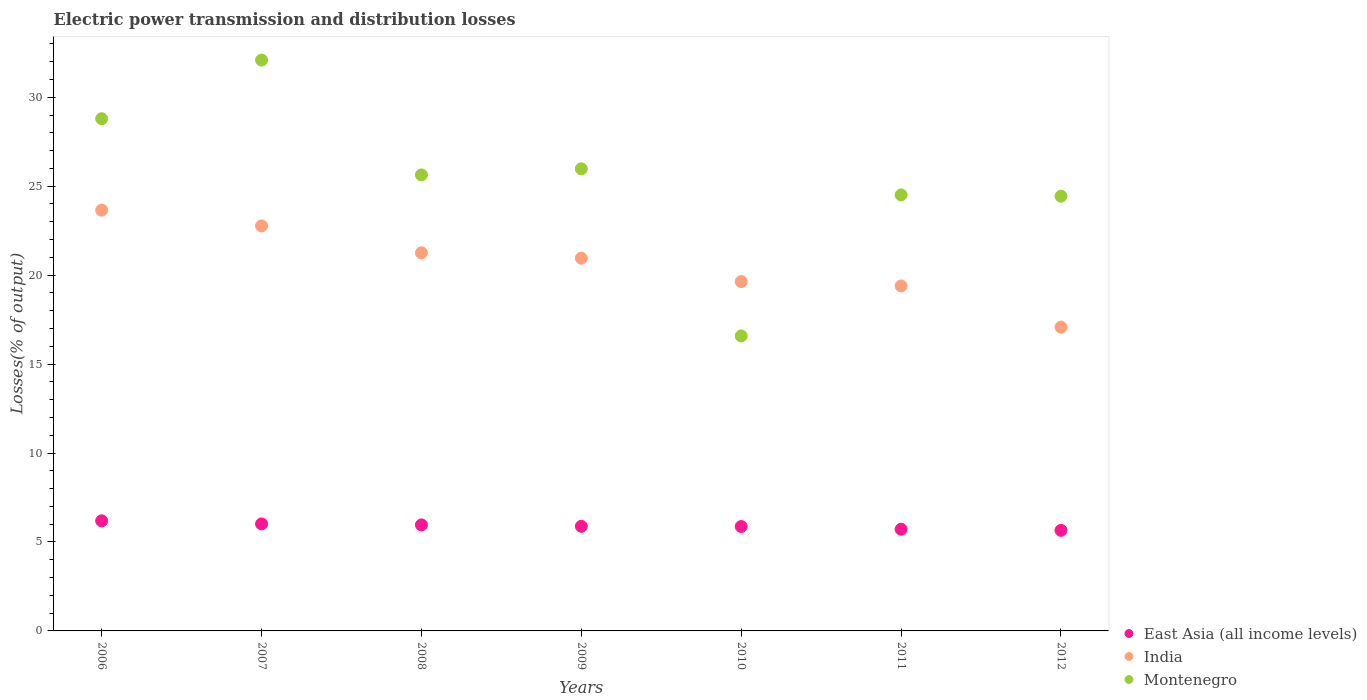What is the electric power transmission and distribution losses in India in 2006?
Ensure brevity in your answer.  23.66. Across all years, what is the maximum electric power transmission and distribution losses in India?
Make the answer very short. 23.66. Across all years, what is the minimum electric power transmission and distribution losses in East Asia (all income levels)?
Offer a very short reply. 5.65. In which year was the electric power transmission and distribution losses in India minimum?
Offer a terse response. 2012. What is the total electric power transmission and distribution losses in Montenegro in the graph?
Make the answer very short. 178.03. What is the difference between the electric power transmission and distribution losses in India in 2008 and that in 2010?
Provide a short and direct response. 1.62. What is the difference between the electric power transmission and distribution losses in India in 2006 and the electric power transmission and distribution losses in East Asia (all income levels) in 2010?
Your response must be concise. 17.79. What is the average electric power transmission and distribution losses in India per year?
Your response must be concise. 20.68. In the year 2007, what is the difference between the electric power transmission and distribution losses in India and electric power transmission and distribution losses in Montenegro?
Provide a short and direct response. -9.32. In how many years, is the electric power transmission and distribution losses in East Asia (all income levels) greater than 24 %?
Your response must be concise. 0. What is the ratio of the electric power transmission and distribution losses in East Asia (all income levels) in 2006 to that in 2012?
Provide a succinct answer. 1.09. What is the difference between the highest and the second highest electric power transmission and distribution losses in East Asia (all income levels)?
Give a very brief answer. 0.17. What is the difference between the highest and the lowest electric power transmission and distribution losses in Montenegro?
Give a very brief answer. 15.51. In how many years, is the electric power transmission and distribution losses in Montenegro greater than the average electric power transmission and distribution losses in Montenegro taken over all years?
Keep it short and to the point. 4. Is the sum of the electric power transmission and distribution losses in Montenegro in 2010 and 2012 greater than the maximum electric power transmission and distribution losses in East Asia (all income levels) across all years?
Ensure brevity in your answer.  Yes. Is the electric power transmission and distribution losses in East Asia (all income levels) strictly greater than the electric power transmission and distribution losses in India over the years?
Your response must be concise. No. Is the electric power transmission and distribution losses in East Asia (all income levels) strictly less than the electric power transmission and distribution losses in Montenegro over the years?
Provide a short and direct response. Yes. Are the values on the major ticks of Y-axis written in scientific E-notation?
Offer a very short reply. No. Does the graph contain grids?
Provide a succinct answer. No. How many legend labels are there?
Provide a short and direct response. 3. How are the legend labels stacked?
Provide a short and direct response. Vertical. What is the title of the graph?
Provide a succinct answer. Electric power transmission and distribution losses. Does "Greece" appear as one of the legend labels in the graph?
Offer a terse response. No. What is the label or title of the Y-axis?
Provide a succinct answer. Losses(% of output). What is the Losses(% of output) in East Asia (all income levels) in 2006?
Your answer should be compact. 6.19. What is the Losses(% of output) in India in 2006?
Keep it short and to the point. 23.66. What is the Losses(% of output) of Montenegro in 2006?
Ensure brevity in your answer.  28.79. What is the Losses(% of output) in East Asia (all income levels) in 2007?
Give a very brief answer. 6.02. What is the Losses(% of output) in India in 2007?
Your answer should be very brief. 22.77. What is the Losses(% of output) in Montenegro in 2007?
Make the answer very short. 32.09. What is the Losses(% of output) in East Asia (all income levels) in 2008?
Ensure brevity in your answer.  5.96. What is the Losses(% of output) of India in 2008?
Offer a very short reply. 21.26. What is the Losses(% of output) of Montenegro in 2008?
Your response must be concise. 25.64. What is the Losses(% of output) in East Asia (all income levels) in 2009?
Offer a very short reply. 5.88. What is the Losses(% of output) in India in 2009?
Make the answer very short. 20.95. What is the Losses(% of output) of Montenegro in 2009?
Provide a succinct answer. 25.98. What is the Losses(% of output) of East Asia (all income levels) in 2010?
Your response must be concise. 5.87. What is the Losses(% of output) in India in 2010?
Ensure brevity in your answer.  19.64. What is the Losses(% of output) in Montenegro in 2010?
Keep it short and to the point. 16.58. What is the Losses(% of output) in East Asia (all income levels) in 2011?
Ensure brevity in your answer.  5.72. What is the Losses(% of output) of India in 2011?
Make the answer very short. 19.39. What is the Losses(% of output) of Montenegro in 2011?
Ensure brevity in your answer.  24.51. What is the Losses(% of output) in East Asia (all income levels) in 2012?
Ensure brevity in your answer.  5.65. What is the Losses(% of output) in India in 2012?
Your answer should be compact. 17.08. What is the Losses(% of output) of Montenegro in 2012?
Give a very brief answer. 24.44. Across all years, what is the maximum Losses(% of output) in East Asia (all income levels)?
Keep it short and to the point. 6.19. Across all years, what is the maximum Losses(% of output) in India?
Keep it short and to the point. 23.66. Across all years, what is the maximum Losses(% of output) of Montenegro?
Provide a short and direct response. 32.09. Across all years, what is the minimum Losses(% of output) of East Asia (all income levels)?
Your response must be concise. 5.65. Across all years, what is the minimum Losses(% of output) in India?
Provide a succinct answer. 17.08. Across all years, what is the minimum Losses(% of output) of Montenegro?
Offer a very short reply. 16.58. What is the total Losses(% of output) in East Asia (all income levels) in the graph?
Offer a terse response. 41.28. What is the total Losses(% of output) in India in the graph?
Give a very brief answer. 144.75. What is the total Losses(% of output) in Montenegro in the graph?
Ensure brevity in your answer.  178.03. What is the difference between the Losses(% of output) of East Asia (all income levels) in 2006 and that in 2007?
Provide a succinct answer. 0.17. What is the difference between the Losses(% of output) of India in 2006 and that in 2007?
Offer a very short reply. 0.89. What is the difference between the Losses(% of output) of Montenegro in 2006 and that in 2007?
Your answer should be compact. -3.3. What is the difference between the Losses(% of output) in East Asia (all income levels) in 2006 and that in 2008?
Make the answer very short. 0.23. What is the difference between the Losses(% of output) in India in 2006 and that in 2008?
Offer a very short reply. 2.4. What is the difference between the Losses(% of output) in Montenegro in 2006 and that in 2008?
Offer a terse response. 3.16. What is the difference between the Losses(% of output) in East Asia (all income levels) in 2006 and that in 2009?
Your answer should be very brief. 0.31. What is the difference between the Losses(% of output) of India in 2006 and that in 2009?
Provide a short and direct response. 2.7. What is the difference between the Losses(% of output) in Montenegro in 2006 and that in 2009?
Give a very brief answer. 2.82. What is the difference between the Losses(% of output) in East Asia (all income levels) in 2006 and that in 2010?
Make the answer very short. 0.32. What is the difference between the Losses(% of output) in India in 2006 and that in 2010?
Make the answer very short. 4.02. What is the difference between the Losses(% of output) of Montenegro in 2006 and that in 2010?
Provide a succinct answer. 12.21. What is the difference between the Losses(% of output) in East Asia (all income levels) in 2006 and that in 2011?
Offer a terse response. 0.47. What is the difference between the Losses(% of output) of India in 2006 and that in 2011?
Your answer should be very brief. 4.26. What is the difference between the Losses(% of output) of Montenegro in 2006 and that in 2011?
Make the answer very short. 4.28. What is the difference between the Losses(% of output) in East Asia (all income levels) in 2006 and that in 2012?
Make the answer very short. 0.54. What is the difference between the Losses(% of output) in India in 2006 and that in 2012?
Your answer should be very brief. 6.58. What is the difference between the Losses(% of output) in Montenegro in 2006 and that in 2012?
Keep it short and to the point. 4.36. What is the difference between the Losses(% of output) in East Asia (all income levels) in 2007 and that in 2008?
Make the answer very short. 0.06. What is the difference between the Losses(% of output) in India in 2007 and that in 2008?
Give a very brief answer. 1.51. What is the difference between the Losses(% of output) in Montenegro in 2007 and that in 2008?
Your answer should be very brief. 6.45. What is the difference between the Losses(% of output) of East Asia (all income levels) in 2007 and that in 2009?
Provide a short and direct response. 0.14. What is the difference between the Losses(% of output) in India in 2007 and that in 2009?
Your answer should be compact. 1.81. What is the difference between the Losses(% of output) of Montenegro in 2007 and that in 2009?
Give a very brief answer. 6.11. What is the difference between the Losses(% of output) of East Asia (all income levels) in 2007 and that in 2010?
Your response must be concise. 0.15. What is the difference between the Losses(% of output) in India in 2007 and that in 2010?
Your response must be concise. 3.13. What is the difference between the Losses(% of output) of Montenegro in 2007 and that in 2010?
Provide a short and direct response. 15.51. What is the difference between the Losses(% of output) in East Asia (all income levels) in 2007 and that in 2011?
Give a very brief answer. 0.3. What is the difference between the Losses(% of output) of India in 2007 and that in 2011?
Provide a short and direct response. 3.37. What is the difference between the Losses(% of output) of Montenegro in 2007 and that in 2011?
Your response must be concise. 7.58. What is the difference between the Losses(% of output) in East Asia (all income levels) in 2007 and that in 2012?
Offer a terse response. 0.36. What is the difference between the Losses(% of output) in India in 2007 and that in 2012?
Offer a very short reply. 5.69. What is the difference between the Losses(% of output) of Montenegro in 2007 and that in 2012?
Keep it short and to the point. 7.65. What is the difference between the Losses(% of output) in East Asia (all income levels) in 2008 and that in 2009?
Offer a very short reply. 0.08. What is the difference between the Losses(% of output) of India in 2008 and that in 2009?
Provide a succinct answer. 0.3. What is the difference between the Losses(% of output) of Montenegro in 2008 and that in 2009?
Make the answer very short. -0.34. What is the difference between the Losses(% of output) of East Asia (all income levels) in 2008 and that in 2010?
Offer a very short reply. 0.09. What is the difference between the Losses(% of output) of India in 2008 and that in 2010?
Offer a very short reply. 1.62. What is the difference between the Losses(% of output) of Montenegro in 2008 and that in 2010?
Give a very brief answer. 9.05. What is the difference between the Losses(% of output) of East Asia (all income levels) in 2008 and that in 2011?
Provide a short and direct response. 0.24. What is the difference between the Losses(% of output) of India in 2008 and that in 2011?
Keep it short and to the point. 1.86. What is the difference between the Losses(% of output) of Montenegro in 2008 and that in 2011?
Provide a short and direct response. 1.13. What is the difference between the Losses(% of output) in East Asia (all income levels) in 2008 and that in 2012?
Your answer should be compact. 0.31. What is the difference between the Losses(% of output) of India in 2008 and that in 2012?
Offer a terse response. 4.18. What is the difference between the Losses(% of output) in Montenegro in 2008 and that in 2012?
Make the answer very short. 1.2. What is the difference between the Losses(% of output) in East Asia (all income levels) in 2009 and that in 2010?
Your answer should be compact. 0.01. What is the difference between the Losses(% of output) in India in 2009 and that in 2010?
Provide a succinct answer. 1.31. What is the difference between the Losses(% of output) of Montenegro in 2009 and that in 2010?
Ensure brevity in your answer.  9.39. What is the difference between the Losses(% of output) of East Asia (all income levels) in 2009 and that in 2011?
Offer a very short reply. 0.16. What is the difference between the Losses(% of output) in India in 2009 and that in 2011?
Your response must be concise. 1.56. What is the difference between the Losses(% of output) in Montenegro in 2009 and that in 2011?
Provide a short and direct response. 1.47. What is the difference between the Losses(% of output) in East Asia (all income levels) in 2009 and that in 2012?
Offer a very short reply. 0.23. What is the difference between the Losses(% of output) in India in 2009 and that in 2012?
Your answer should be compact. 3.87. What is the difference between the Losses(% of output) in Montenegro in 2009 and that in 2012?
Make the answer very short. 1.54. What is the difference between the Losses(% of output) of East Asia (all income levels) in 2010 and that in 2011?
Keep it short and to the point. 0.15. What is the difference between the Losses(% of output) of India in 2010 and that in 2011?
Ensure brevity in your answer.  0.25. What is the difference between the Losses(% of output) in Montenegro in 2010 and that in 2011?
Your response must be concise. -7.93. What is the difference between the Losses(% of output) of East Asia (all income levels) in 2010 and that in 2012?
Your answer should be very brief. 0.21. What is the difference between the Losses(% of output) in India in 2010 and that in 2012?
Your answer should be compact. 2.56. What is the difference between the Losses(% of output) of Montenegro in 2010 and that in 2012?
Make the answer very short. -7.85. What is the difference between the Losses(% of output) in East Asia (all income levels) in 2011 and that in 2012?
Provide a succinct answer. 0.06. What is the difference between the Losses(% of output) in India in 2011 and that in 2012?
Your response must be concise. 2.32. What is the difference between the Losses(% of output) in Montenegro in 2011 and that in 2012?
Provide a short and direct response. 0.07. What is the difference between the Losses(% of output) of East Asia (all income levels) in 2006 and the Losses(% of output) of India in 2007?
Your answer should be very brief. -16.58. What is the difference between the Losses(% of output) in East Asia (all income levels) in 2006 and the Losses(% of output) in Montenegro in 2007?
Your answer should be very brief. -25.9. What is the difference between the Losses(% of output) in India in 2006 and the Losses(% of output) in Montenegro in 2007?
Your response must be concise. -8.43. What is the difference between the Losses(% of output) of East Asia (all income levels) in 2006 and the Losses(% of output) of India in 2008?
Your answer should be very brief. -15.07. What is the difference between the Losses(% of output) of East Asia (all income levels) in 2006 and the Losses(% of output) of Montenegro in 2008?
Give a very brief answer. -19.45. What is the difference between the Losses(% of output) in India in 2006 and the Losses(% of output) in Montenegro in 2008?
Provide a short and direct response. -1.98. What is the difference between the Losses(% of output) of East Asia (all income levels) in 2006 and the Losses(% of output) of India in 2009?
Your answer should be very brief. -14.76. What is the difference between the Losses(% of output) in East Asia (all income levels) in 2006 and the Losses(% of output) in Montenegro in 2009?
Your response must be concise. -19.79. What is the difference between the Losses(% of output) of India in 2006 and the Losses(% of output) of Montenegro in 2009?
Offer a terse response. -2.32. What is the difference between the Losses(% of output) of East Asia (all income levels) in 2006 and the Losses(% of output) of India in 2010?
Your answer should be compact. -13.45. What is the difference between the Losses(% of output) of East Asia (all income levels) in 2006 and the Losses(% of output) of Montenegro in 2010?
Ensure brevity in your answer.  -10.39. What is the difference between the Losses(% of output) of India in 2006 and the Losses(% of output) of Montenegro in 2010?
Your answer should be very brief. 7.07. What is the difference between the Losses(% of output) in East Asia (all income levels) in 2006 and the Losses(% of output) in India in 2011?
Your answer should be compact. -13.21. What is the difference between the Losses(% of output) of East Asia (all income levels) in 2006 and the Losses(% of output) of Montenegro in 2011?
Make the answer very short. -18.32. What is the difference between the Losses(% of output) of India in 2006 and the Losses(% of output) of Montenegro in 2011?
Keep it short and to the point. -0.85. What is the difference between the Losses(% of output) in East Asia (all income levels) in 2006 and the Losses(% of output) in India in 2012?
Offer a terse response. -10.89. What is the difference between the Losses(% of output) in East Asia (all income levels) in 2006 and the Losses(% of output) in Montenegro in 2012?
Offer a terse response. -18.25. What is the difference between the Losses(% of output) of India in 2006 and the Losses(% of output) of Montenegro in 2012?
Keep it short and to the point. -0.78. What is the difference between the Losses(% of output) of East Asia (all income levels) in 2007 and the Losses(% of output) of India in 2008?
Your response must be concise. -15.24. What is the difference between the Losses(% of output) of East Asia (all income levels) in 2007 and the Losses(% of output) of Montenegro in 2008?
Your response must be concise. -19.62. What is the difference between the Losses(% of output) in India in 2007 and the Losses(% of output) in Montenegro in 2008?
Offer a very short reply. -2.87. What is the difference between the Losses(% of output) of East Asia (all income levels) in 2007 and the Losses(% of output) of India in 2009?
Give a very brief answer. -14.94. What is the difference between the Losses(% of output) in East Asia (all income levels) in 2007 and the Losses(% of output) in Montenegro in 2009?
Offer a terse response. -19.96. What is the difference between the Losses(% of output) in India in 2007 and the Losses(% of output) in Montenegro in 2009?
Provide a succinct answer. -3.21. What is the difference between the Losses(% of output) in East Asia (all income levels) in 2007 and the Losses(% of output) in India in 2010?
Provide a succinct answer. -13.62. What is the difference between the Losses(% of output) in East Asia (all income levels) in 2007 and the Losses(% of output) in Montenegro in 2010?
Ensure brevity in your answer.  -10.57. What is the difference between the Losses(% of output) in India in 2007 and the Losses(% of output) in Montenegro in 2010?
Offer a terse response. 6.18. What is the difference between the Losses(% of output) of East Asia (all income levels) in 2007 and the Losses(% of output) of India in 2011?
Offer a terse response. -13.38. What is the difference between the Losses(% of output) of East Asia (all income levels) in 2007 and the Losses(% of output) of Montenegro in 2011?
Offer a very short reply. -18.49. What is the difference between the Losses(% of output) of India in 2007 and the Losses(% of output) of Montenegro in 2011?
Offer a very short reply. -1.74. What is the difference between the Losses(% of output) of East Asia (all income levels) in 2007 and the Losses(% of output) of India in 2012?
Give a very brief answer. -11.06. What is the difference between the Losses(% of output) of East Asia (all income levels) in 2007 and the Losses(% of output) of Montenegro in 2012?
Offer a very short reply. -18.42. What is the difference between the Losses(% of output) of India in 2007 and the Losses(% of output) of Montenegro in 2012?
Your answer should be very brief. -1.67. What is the difference between the Losses(% of output) in East Asia (all income levels) in 2008 and the Losses(% of output) in India in 2009?
Offer a terse response. -14.99. What is the difference between the Losses(% of output) of East Asia (all income levels) in 2008 and the Losses(% of output) of Montenegro in 2009?
Keep it short and to the point. -20.02. What is the difference between the Losses(% of output) of India in 2008 and the Losses(% of output) of Montenegro in 2009?
Keep it short and to the point. -4.72. What is the difference between the Losses(% of output) of East Asia (all income levels) in 2008 and the Losses(% of output) of India in 2010?
Ensure brevity in your answer.  -13.68. What is the difference between the Losses(% of output) in East Asia (all income levels) in 2008 and the Losses(% of output) in Montenegro in 2010?
Your answer should be very brief. -10.62. What is the difference between the Losses(% of output) in India in 2008 and the Losses(% of output) in Montenegro in 2010?
Your answer should be compact. 4.67. What is the difference between the Losses(% of output) of East Asia (all income levels) in 2008 and the Losses(% of output) of India in 2011?
Give a very brief answer. -13.43. What is the difference between the Losses(% of output) in East Asia (all income levels) in 2008 and the Losses(% of output) in Montenegro in 2011?
Offer a very short reply. -18.55. What is the difference between the Losses(% of output) of India in 2008 and the Losses(% of output) of Montenegro in 2011?
Give a very brief answer. -3.26. What is the difference between the Losses(% of output) in East Asia (all income levels) in 2008 and the Losses(% of output) in India in 2012?
Offer a very short reply. -11.12. What is the difference between the Losses(% of output) in East Asia (all income levels) in 2008 and the Losses(% of output) in Montenegro in 2012?
Give a very brief answer. -18.48. What is the difference between the Losses(% of output) in India in 2008 and the Losses(% of output) in Montenegro in 2012?
Keep it short and to the point. -3.18. What is the difference between the Losses(% of output) in East Asia (all income levels) in 2009 and the Losses(% of output) in India in 2010?
Your answer should be very brief. -13.76. What is the difference between the Losses(% of output) of East Asia (all income levels) in 2009 and the Losses(% of output) of Montenegro in 2010?
Provide a short and direct response. -10.7. What is the difference between the Losses(% of output) in India in 2009 and the Losses(% of output) in Montenegro in 2010?
Provide a succinct answer. 4.37. What is the difference between the Losses(% of output) in East Asia (all income levels) in 2009 and the Losses(% of output) in India in 2011?
Offer a very short reply. -13.51. What is the difference between the Losses(% of output) of East Asia (all income levels) in 2009 and the Losses(% of output) of Montenegro in 2011?
Your answer should be compact. -18.63. What is the difference between the Losses(% of output) of India in 2009 and the Losses(% of output) of Montenegro in 2011?
Your answer should be compact. -3.56. What is the difference between the Losses(% of output) in East Asia (all income levels) in 2009 and the Losses(% of output) in India in 2012?
Ensure brevity in your answer.  -11.2. What is the difference between the Losses(% of output) in East Asia (all income levels) in 2009 and the Losses(% of output) in Montenegro in 2012?
Make the answer very short. -18.56. What is the difference between the Losses(% of output) of India in 2009 and the Losses(% of output) of Montenegro in 2012?
Provide a short and direct response. -3.48. What is the difference between the Losses(% of output) in East Asia (all income levels) in 2010 and the Losses(% of output) in India in 2011?
Make the answer very short. -13.53. What is the difference between the Losses(% of output) in East Asia (all income levels) in 2010 and the Losses(% of output) in Montenegro in 2011?
Provide a short and direct response. -18.64. What is the difference between the Losses(% of output) in India in 2010 and the Losses(% of output) in Montenegro in 2011?
Provide a short and direct response. -4.87. What is the difference between the Losses(% of output) in East Asia (all income levels) in 2010 and the Losses(% of output) in India in 2012?
Make the answer very short. -11.21. What is the difference between the Losses(% of output) in East Asia (all income levels) in 2010 and the Losses(% of output) in Montenegro in 2012?
Make the answer very short. -18.57. What is the difference between the Losses(% of output) in India in 2010 and the Losses(% of output) in Montenegro in 2012?
Provide a short and direct response. -4.8. What is the difference between the Losses(% of output) of East Asia (all income levels) in 2011 and the Losses(% of output) of India in 2012?
Provide a succinct answer. -11.36. What is the difference between the Losses(% of output) of East Asia (all income levels) in 2011 and the Losses(% of output) of Montenegro in 2012?
Your response must be concise. -18.72. What is the difference between the Losses(% of output) in India in 2011 and the Losses(% of output) in Montenegro in 2012?
Your answer should be compact. -5.04. What is the average Losses(% of output) of East Asia (all income levels) per year?
Offer a terse response. 5.9. What is the average Losses(% of output) in India per year?
Keep it short and to the point. 20.68. What is the average Losses(% of output) in Montenegro per year?
Make the answer very short. 25.43. In the year 2006, what is the difference between the Losses(% of output) in East Asia (all income levels) and Losses(% of output) in India?
Your answer should be compact. -17.47. In the year 2006, what is the difference between the Losses(% of output) of East Asia (all income levels) and Losses(% of output) of Montenegro?
Your response must be concise. -22.6. In the year 2006, what is the difference between the Losses(% of output) of India and Losses(% of output) of Montenegro?
Offer a terse response. -5.14. In the year 2007, what is the difference between the Losses(% of output) in East Asia (all income levels) and Losses(% of output) in India?
Your answer should be very brief. -16.75. In the year 2007, what is the difference between the Losses(% of output) in East Asia (all income levels) and Losses(% of output) in Montenegro?
Offer a very short reply. -26.07. In the year 2007, what is the difference between the Losses(% of output) of India and Losses(% of output) of Montenegro?
Keep it short and to the point. -9.32. In the year 2008, what is the difference between the Losses(% of output) of East Asia (all income levels) and Losses(% of output) of India?
Your answer should be very brief. -15.3. In the year 2008, what is the difference between the Losses(% of output) of East Asia (all income levels) and Losses(% of output) of Montenegro?
Give a very brief answer. -19.68. In the year 2008, what is the difference between the Losses(% of output) in India and Losses(% of output) in Montenegro?
Keep it short and to the point. -4.38. In the year 2009, what is the difference between the Losses(% of output) in East Asia (all income levels) and Losses(% of output) in India?
Keep it short and to the point. -15.07. In the year 2009, what is the difference between the Losses(% of output) in East Asia (all income levels) and Losses(% of output) in Montenegro?
Keep it short and to the point. -20.1. In the year 2009, what is the difference between the Losses(% of output) in India and Losses(% of output) in Montenegro?
Provide a short and direct response. -5.02. In the year 2010, what is the difference between the Losses(% of output) in East Asia (all income levels) and Losses(% of output) in India?
Your response must be concise. -13.77. In the year 2010, what is the difference between the Losses(% of output) in East Asia (all income levels) and Losses(% of output) in Montenegro?
Your response must be concise. -10.71. In the year 2010, what is the difference between the Losses(% of output) of India and Losses(% of output) of Montenegro?
Keep it short and to the point. 3.06. In the year 2011, what is the difference between the Losses(% of output) of East Asia (all income levels) and Losses(% of output) of India?
Give a very brief answer. -13.68. In the year 2011, what is the difference between the Losses(% of output) of East Asia (all income levels) and Losses(% of output) of Montenegro?
Your answer should be very brief. -18.79. In the year 2011, what is the difference between the Losses(% of output) of India and Losses(% of output) of Montenegro?
Offer a very short reply. -5.12. In the year 2012, what is the difference between the Losses(% of output) of East Asia (all income levels) and Losses(% of output) of India?
Offer a very short reply. -11.42. In the year 2012, what is the difference between the Losses(% of output) in East Asia (all income levels) and Losses(% of output) in Montenegro?
Make the answer very short. -18.78. In the year 2012, what is the difference between the Losses(% of output) of India and Losses(% of output) of Montenegro?
Keep it short and to the point. -7.36. What is the ratio of the Losses(% of output) in East Asia (all income levels) in 2006 to that in 2007?
Your answer should be very brief. 1.03. What is the ratio of the Losses(% of output) of India in 2006 to that in 2007?
Keep it short and to the point. 1.04. What is the ratio of the Losses(% of output) of Montenegro in 2006 to that in 2007?
Your response must be concise. 0.9. What is the ratio of the Losses(% of output) in East Asia (all income levels) in 2006 to that in 2008?
Provide a succinct answer. 1.04. What is the ratio of the Losses(% of output) in India in 2006 to that in 2008?
Make the answer very short. 1.11. What is the ratio of the Losses(% of output) in Montenegro in 2006 to that in 2008?
Make the answer very short. 1.12. What is the ratio of the Losses(% of output) in East Asia (all income levels) in 2006 to that in 2009?
Provide a succinct answer. 1.05. What is the ratio of the Losses(% of output) in India in 2006 to that in 2009?
Offer a very short reply. 1.13. What is the ratio of the Losses(% of output) of Montenegro in 2006 to that in 2009?
Your answer should be compact. 1.11. What is the ratio of the Losses(% of output) in East Asia (all income levels) in 2006 to that in 2010?
Make the answer very short. 1.05. What is the ratio of the Losses(% of output) of India in 2006 to that in 2010?
Keep it short and to the point. 1.2. What is the ratio of the Losses(% of output) in Montenegro in 2006 to that in 2010?
Ensure brevity in your answer.  1.74. What is the ratio of the Losses(% of output) in East Asia (all income levels) in 2006 to that in 2011?
Your response must be concise. 1.08. What is the ratio of the Losses(% of output) in India in 2006 to that in 2011?
Your answer should be compact. 1.22. What is the ratio of the Losses(% of output) of Montenegro in 2006 to that in 2011?
Provide a succinct answer. 1.17. What is the ratio of the Losses(% of output) in East Asia (all income levels) in 2006 to that in 2012?
Keep it short and to the point. 1.09. What is the ratio of the Losses(% of output) of India in 2006 to that in 2012?
Ensure brevity in your answer.  1.39. What is the ratio of the Losses(% of output) in Montenegro in 2006 to that in 2012?
Offer a very short reply. 1.18. What is the ratio of the Losses(% of output) of East Asia (all income levels) in 2007 to that in 2008?
Make the answer very short. 1.01. What is the ratio of the Losses(% of output) in India in 2007 to that in 2008?
Provide a short and direct response. 1.07. What is the ratio of the Losses(% of output) in Montenegro in 2007 to that in 2008?
Give a very brief answer. 1.25. What is the ratio of the Losses(% of output) in India in 2007 to that in 2009?
Offer a terse response. 1.09. What is the ratio of the Losses(% of output) of Montenegro in 2007 to that in 2009?
Offer a very short reply. 1.24. What is the ratio of the Losses(% of output) of East Asia (all income levels) in 2007 to that in 2010?
Give a very brief answer. 1.02. What is the ratio of the Losses(% of output) of India in 2007 to that in 2010?
Keep it short and to the point. 1.16. What is the ratio of the Losses(% of output) in Montenegro in 2007 to that in 2010?
Give a very brief answer. 1.94. What is the ratio of the Losses(% of output) in East Asia (all income levels) in 2007 to that in 2011?
Your answer should be compact. 1.05. What is the ratio of the Losses(% of output) in India in 2007 to that in 2011?
Offer a terse response. 1.17. What is the ratio of the Losses(% of output) of Montenegro in 2007 to that in 2011?
Your answer should be very brief. 1.31. What is the ratio of the Losses(% of output) of East Asia (all income levels) in 2007 to that in 2012?
Provide a short and direct response. 1.06. What is the ratio of the Losses(% of output) in India in 2007 to that in 2012?
Offer a very short reply. 1.33. What is the ratio of the Losses(% of output) in Montenegro in 2007 to that in 2012?
Your answer should be very brief. 1.31. What is the ratio of the Losses(% of output) in East Asia (all income levels) in 2008 to that in 2009?
Offer a very short reply. 1.01. What is the ratio of the Losses(% of output) in India in 2008 to that in 2009?
Make the answer very short. 1.01. What is the ratio of the Losses(% of output) in Montenegro in 2008 to that in 2009?
Your answer should be compact. 0.99. What is the ratio of the Losses(% of output) of East Asia (all income levels) in 2008 to that in 2010?
Your response must be concise. 1.02. What is the ratio of the Losses(% of output) in India in 2008 to that in 2010?
Offer a terse response. 1.08. What is the ratio of the Losses(% of output) of Montenegro in 2008 to that in 2010?
Make the answer very short. 1.55. What is the ratio of the Losses(% of output) of East Asia (all income levels) in 2008 to that in 2011?
Make the answer very short. 1.04. What is the ratio of the Losses(% of output) of India in 2008 to that in 2011?
Your answer should be very brief. 1.1. What is the ratio of the Losses(% of output) in Montenegro in 2008 to that in 2011?
Your answer should be very brief. 1.05. What is the ratio of the Losses(% of output) in East Asia (all income levels) in 2008 to that in 2012?
Provide a succinct answer. 1.05. What is the ratio of the Losses(% of output) in India in 2008 to that in 2012?
Offer a terse response. 1.24. What is the ratio of the Losses(% of output) in Montenegro in 2008 to that in 2012?
Your answer should be compact. 1.05. What is the ratio of the Losses(% of output) of East Asia (all income levels) in 2009 to that in 2010?
Ensure brevity in your answer.  1. What is the ratio of the Losses(% of output) of India in 2009 to that in 2010?
Your response must be concise. 1.07. What is the ratio of the Losses(% of output) in Montenegro in 2009 to that in 2010?
Keep it short and to the point. 1.57. What is the ratio of the Losses(% of output) of East Asia (all income levels) in 2009 to that in 2011?
Keep it short and to the point. 1.03. What is the ratio of the Losses(% of output) of India in 2009 to that in 2011?
Your answer should be compact. 1.08. What is the ratio of the Losses(% of output) in Montenegro in 2009 to that in 2011?
Make the answer very short. 1.06. What is the ratio of the Losses(% of output) in India in 2009 to that in 2012?
Your answer should be very brief. 1.23. What is the ratio of the Losses(% of output) of Montenegro in 2009 to that in 2012?
Ensure brevity in your answer.  1.06. What is the ratio of the Losses(% of output) in East Asia (all income levels) in 2010 to that in 2011?
Your answer should be compact. 1.03. What is the ratio of the Losses(% of output) of India in 2010 to that in 2011?
Provide a short and direct response. 1.01. What is the ratio of the Losses(% of output) of Montenegro in 2010 to that in 2011?
Provide a succinct answer. 0.68. What is the ratio of the Losses(% of output) of East Asia (all income levels) in 2010 to that in 2012?
Offer a very short reply. 1.04. What is the ratio of the Losses(% of output) of India in 2010 to that in 2012?
Give a very brief answer. 1.15. What is the ratio of the Losses(% of output) in Montenegro in 2010 to that in 2012?
Your answer should be very brief. 0.68. What is the ratio of the Losses(% of output) in East Asia (all income levels) in 2011 to that in 2012?
Keep it short and to the point. 1.01. What is the ratio of the Losses(% of output) of India in 2011 to that in 2012?
Make the answer very short. 1.14. What is the ratio of the Losses(% of output) in Montenegro in 2011 to that in 2012?
Offer a very short reply. 1. What is the difference between the highest and the second highest Losses(% of output) in East Asia (all income levels)?
Your answer should be compact. 0.17. What is the difference between the highest and the second highest Losses(% of output) in India?
Your answer should be compact. 0.89. What is the difference between the highest and the second highest Losses(% of output) of Montenegro?
Provide a short and direct response. 3.3. What is the difference between the highest and the lowest Losses(% of output) of East Asia (all income levels)?
Give a very brief answer. 0.54. What is the difference between the highest and the lowest Losses(% of output) of India?
Your response must be concise. 6.58. What is the difference between the highest and the lowest Losses(% of output) in Montenegro?
Your answer should be compact. 15.51. 